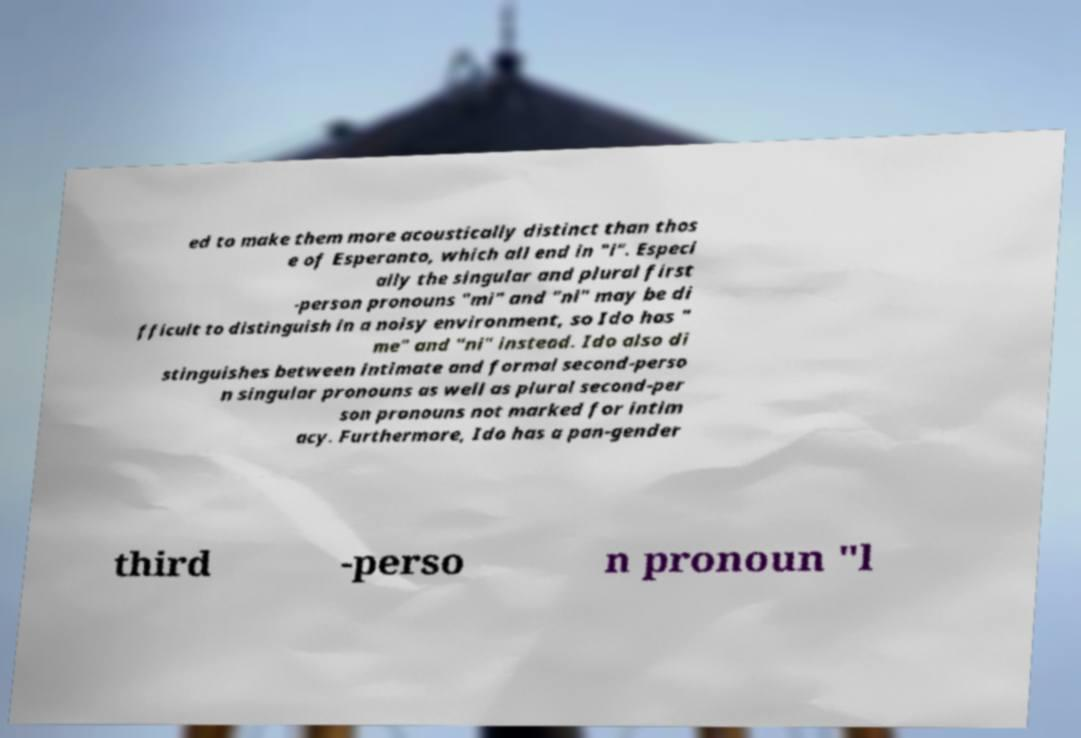Please identify and transcribe the text found in this image. ed to make them more acoustically distinct than thos e of Esperanto, which all end in "i". Especi ally the singular and plural first -person pronouns "mi" and "ni" may be di fficult to distinguish in a noisy environment, so Ido has " me" and "ni" instead. Ido also di stinguishes between intimate and formal second-perso n singular pronouns as well as plural second-per son pronouns not marked for intim acy. Furthermore, Ido has a pan-gender third -perso n pronoun "l 